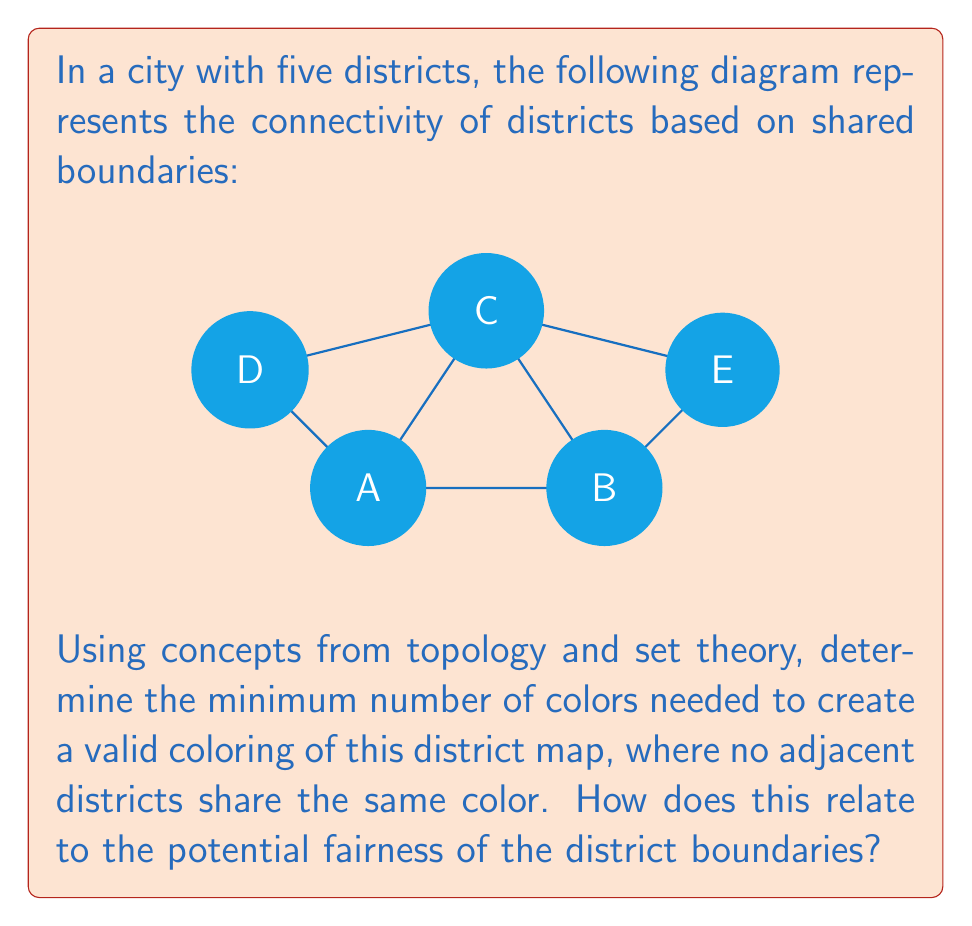Could you help me with this problem? To solve this problem, we'll use the following steps:

1. Recognize that this is a graph coloring problem, where each district is a vertex and shared boundaries are edges.

2. Apply the Four Color Theorem, which states that any planar graph can be colored using at most four colors.

3. Analyze the given graph:
   - District C shares boundaries with all other districts.
   - Districts A and B are adjacent.
   - Districts D and E are not adjacent to each other.

4. Determine the chromatic number (minimum number of colors needed):
   - Assign color 1 to district C.
   - Assign color 2 to districts A and E.
   - Assign color 3 to districts B and D.

5. Verify that no adjacent districts share the same color.

6. Relate to fairness:
   - A lower chromatic number suggests more intertwined districts, potentially indicating more balanced representation.
   - In this case, 3 colors are needed, which is less than the maximum of 4 for a planar graph.
   - This suggests a moderate level of district intermingling, neither extremely segregated nor fully integrated.

The chromatic number χ(G) for this graph is 3, which can be expressed mathematically as:

$$ χ(G) = min \{k : ∃f: V → \{1, ..., k\} \text{ such that } f(u) ≠ f(v) \text{ for all } (u,v) ∈ E\} = 3 $$

Where G is the graph, V is the set of vertices, and E is the set of edges.
Answer: 3 colors; moderate fairness 